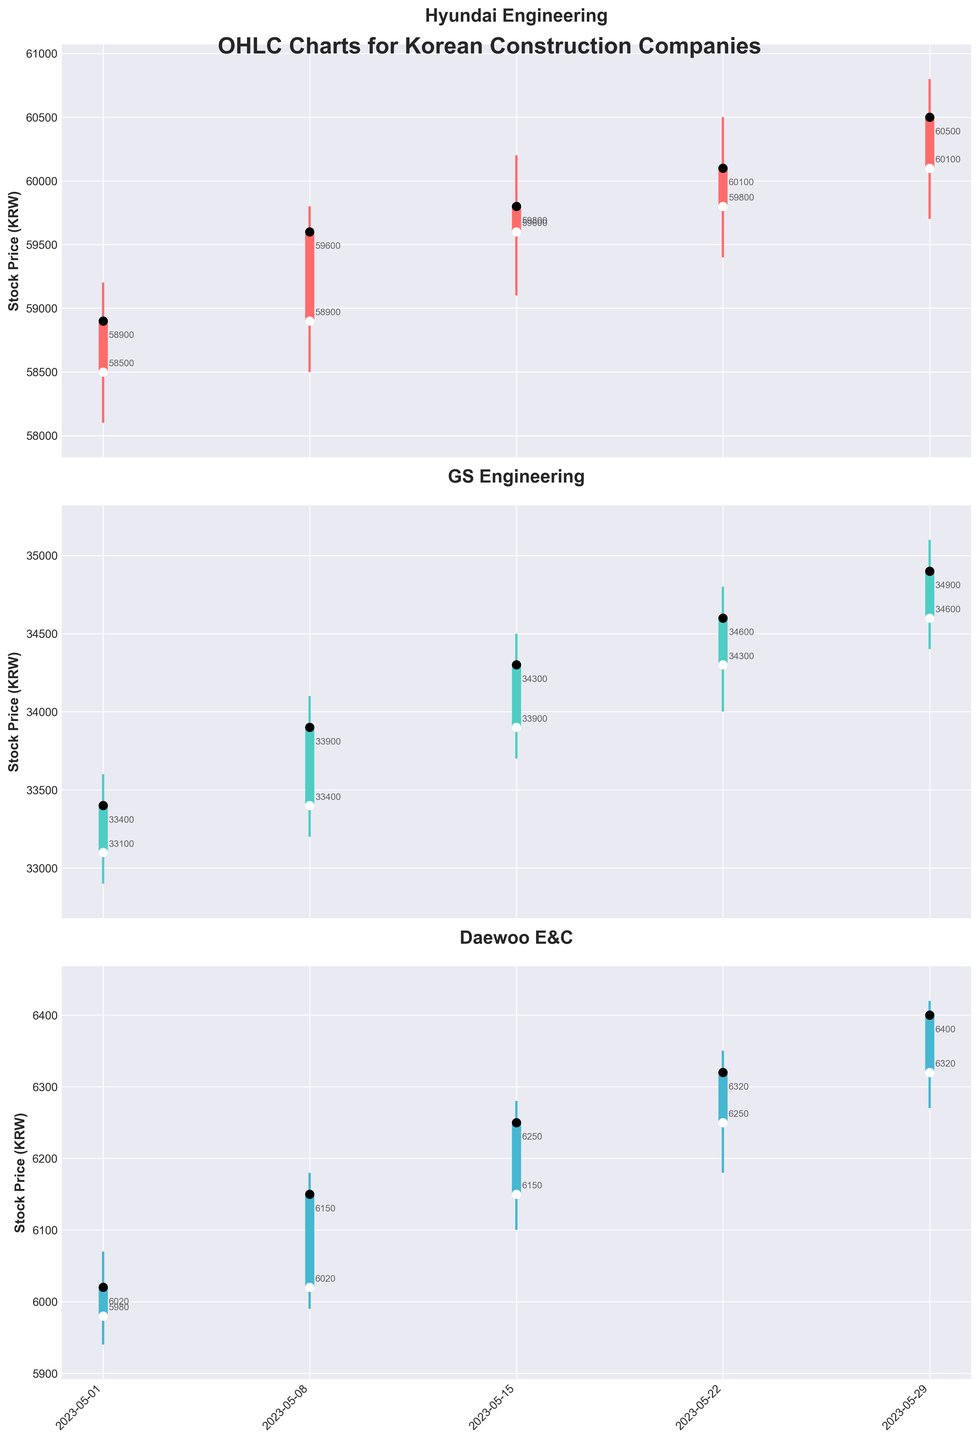How many companies' stock prices are shown in the OHLC chart? The OHLC chart displays three different subplots, each representing a distinct company. The companies mentioned in the dataset are Hyundai Engineering, GS Engineering, and Daewoo E&C. By counting these companies, we conclude that there are three companies in total.
Answer: 3 Which company had the highest closing price on May 29, 2023? By examining the OHLC chart for May 29, 2023, we compare the closing prices of the three companies. Hyundai Engineering had a closing price of 60,500 KRW, GS Engineering had a closing price of 34,900 KRW, and Daewoo E&C had a closing price of 6,400 KRW. Among these, Hyundai Engineering had the highest closing price.
Answer: Hyundai Engineering What is the range of stock prices for GS Engineering on May 15, 2023? The range of stock prices is calculated by subtracting the day's lowest price from the highest price. For GS Engineering on May 15, 2023, the highest price was 34,500 KRW, and the lowest price was 33,700 KRW. Thus, the range is 34,500 - 33,700 = 800 KRW.
Answer: 800 KRW Which company had the most significant increase in closing price from May 8, 2023, to May 15, 2023? To determine the most significant increase, we examine the closing prices on May 8 and May 15. Hyundai Engineering increased from 59,600 to 59,800 KRW (200 KRW increase), GS Engineering increased from 33,900 to 34,300 KRW (400 KRW increase), and Daewoo E&C increased from 6,150 to 6,250 KRW (100 KRW increase). GS Engineering had the most significant increase of 400 KRW.
Answer: GS Engineering How many times did Daewoo E&C’s closing price exceed 6,000 KRW in May 2023? We look at the closing prices of Daewoo E&C for each date in May 2023: May 1 (6,020 KRW), May 8 (6,150 KRW), May 15 (6,250 KRW), May 22 (6,320 KRW), and May 29 (6,400 KRW). Each closing price exceeded 6,000 KRW. By counting the instances, we find that it exceeded 6,000 KRW five times.
Answer: 5 Between Hyundai Engineering and GS Engineering, which company had a higher average high price in May 2023? First, we calculate the average high prices for each company in May 2023. For Hyundai Engineering: (59,200 + 59,800 + 60,200 + 60,500 + 60,800) / 5 = 60,100 KRW. For GS Engineering: (33,600 + 34,100 + 34,500 + 34,800 + 35,100) / 5 = 34,420 KRW. Hyundai Engineering had a higher average high price.
Answer: Hyundai Engineering What is the overall trend in the closing prices of GS Engineering throughout May 2023? By examining the closing prices for GS Engineering on each date: May 1 (33,400 KRW), May 8 (33,900 KRW), May 15 (34,300 KRW), May 22 (34,600 KRW), and May 29 (34,900 KRW), we see a consistently increasing trend in the closing prices throughout the month.
Answer: Increasing 